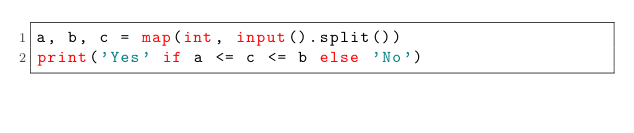<code> <loc_0><loc_0><loc_500><loc_500><_Python_>a, b, c = map(int, input().split())
print('Yes' if a <= c <= b else 'No')
</code> 